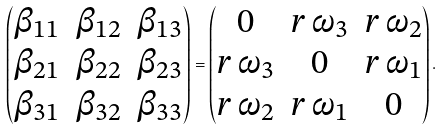<formula> <loc_0><loc_0><loc_500><loc_500>\begin{pmatrix} \beta _ { 1 1 } & \beta _ { 1 2 } & \beta _ { 1 3 } \\ \beta _ { 2 1 } & \beta _ { 2 2 } & \beta _ { 2 3 } \\ \beta _ { 3 1 } & \beta _ { 3 2 } & \beta _ { 3 3 } \end{pmatrix} = \begin{pmatrix} 0 & r \, \omega _ { 3 } & r \, \omega _ { 2 } \\ r \, \omega _ { 3 } & 0 & r \, \omega _ { 1 } \\ r \, \omega _ { 2 } & r \, \omega _ { 1 } & 0 \end{pmatrix} .</formula> 